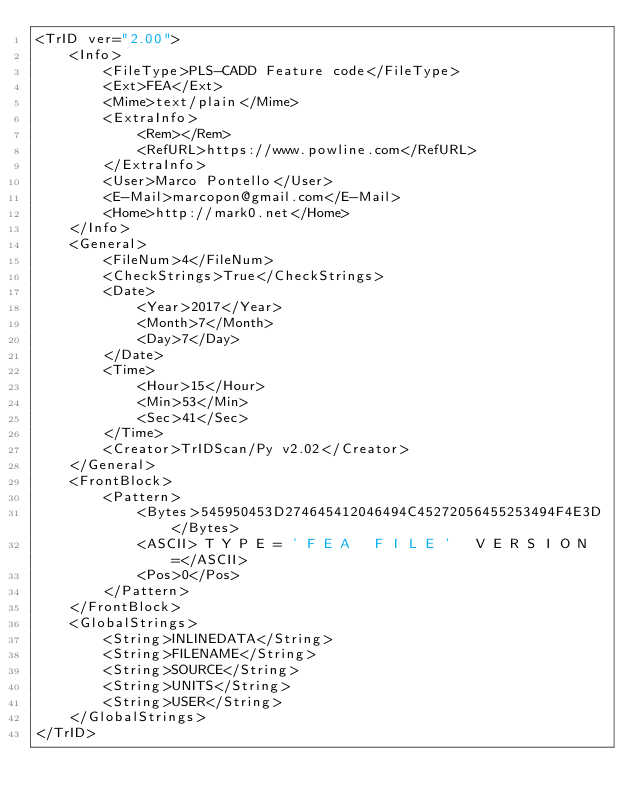Convert code to text. <code><loc_0><loc_0><loc_500><loc_500><_XML_><TrID ver="2.00">
	<Info>
		<FileType>PLS-CADD Feature code</FileType>
		<Ext>FEA</Ext>
		<Mime>text/plain</Mime>
		<ExtraInfo>
			<Rem></Rem>
			<RefURL>https://www.powline.com</RefURL>
		</ExtraInfo>
		<User>Marco Pontello</User>
		<E-Mail>marcopon@gmail.com</E-Mail>
		<Home>http://mark0.net</Home>
	</Info>
	<General>
		<FileNum>4</FileNum>
		<CheckStrings>True</CheckStrings>
		<Date>
			<Year>2017</Year>
			<Month>7</Month>
			<Day>7</Day>
		</Date>
		<Time>
			<Hour>15</Hour>
			<Min>53</Min>
			<Sec>41</Sec>
		</Time>
		<Creator>TrIDScan/Py v2.02</Creator>
	</General>
	<FrontBlock>
		<Pattern>
			<Bytes>545950453D274645412046494C45272056455253494F4E3D</Bytes>
			<ASCII> T Y P E = ' F E A   F I L E '   V E R S I O N =</ASCII>
			<Pos>0</Pos>
		</Pattern>
	</FrontBlock>
	<GlobalStrings>
		<String>INLINEDATA</String>
		<String>FILENAME</String>
		<String>SOURCE</String>
		<String>UNITS</String>
		<String>USER</String>
	</GlobalStrings>
</TrID></code> 